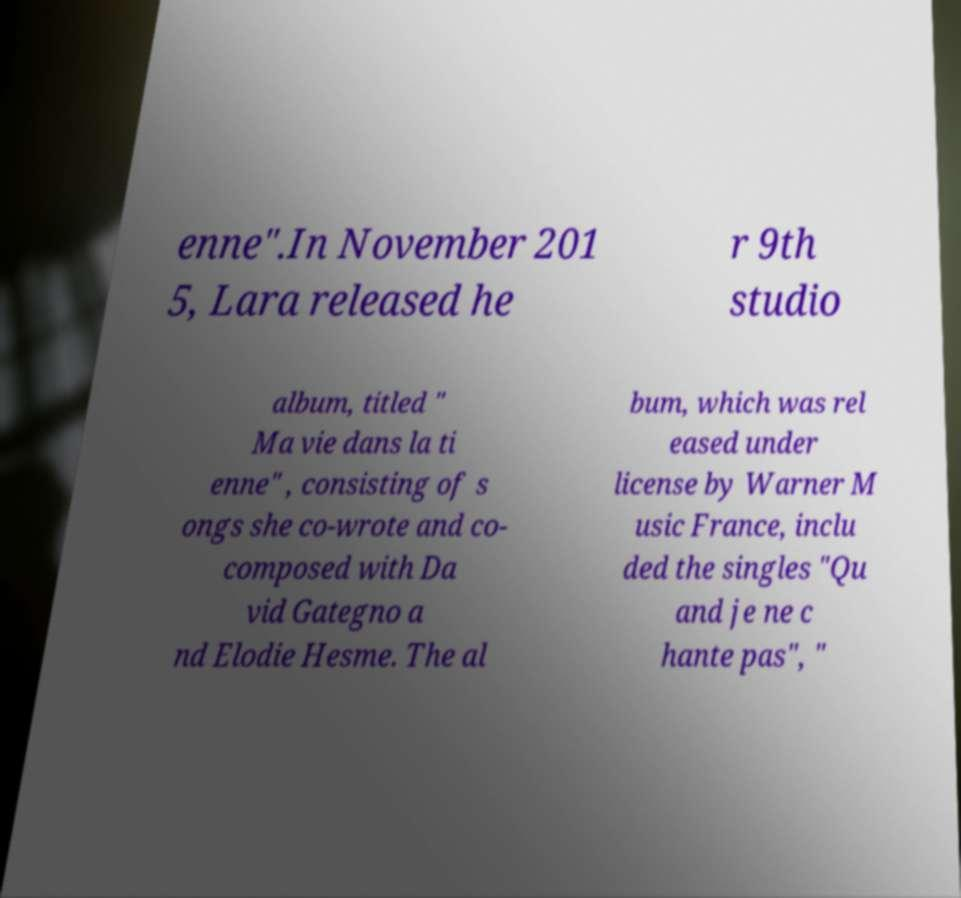I need the written content from this picture converted into text. Can you do that? enne".In November 201 5, Lara released he r 9th studio album, titled " Ma vie dans la ti enne" , consisting of s ongs she co-wrote and co- composed with Da vid Gategno a nd Elodie Hesme. The al bum, which was rel eased under license by Warner M usic France, inclu ded the singles "Qu and je ne c hante pas", " 